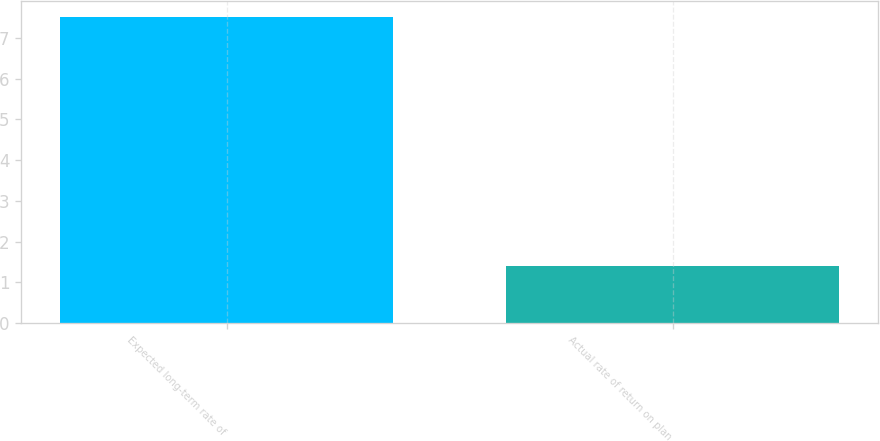Convert chart to OTSL. <chart><loc_0><loc_0><loc_500><loc_500><bar_chart><fcel>Expected long-term rate of<fcel>Actual rate of return on plan<nl><fcel>7.52<fcel>1.4<nl></chart> 